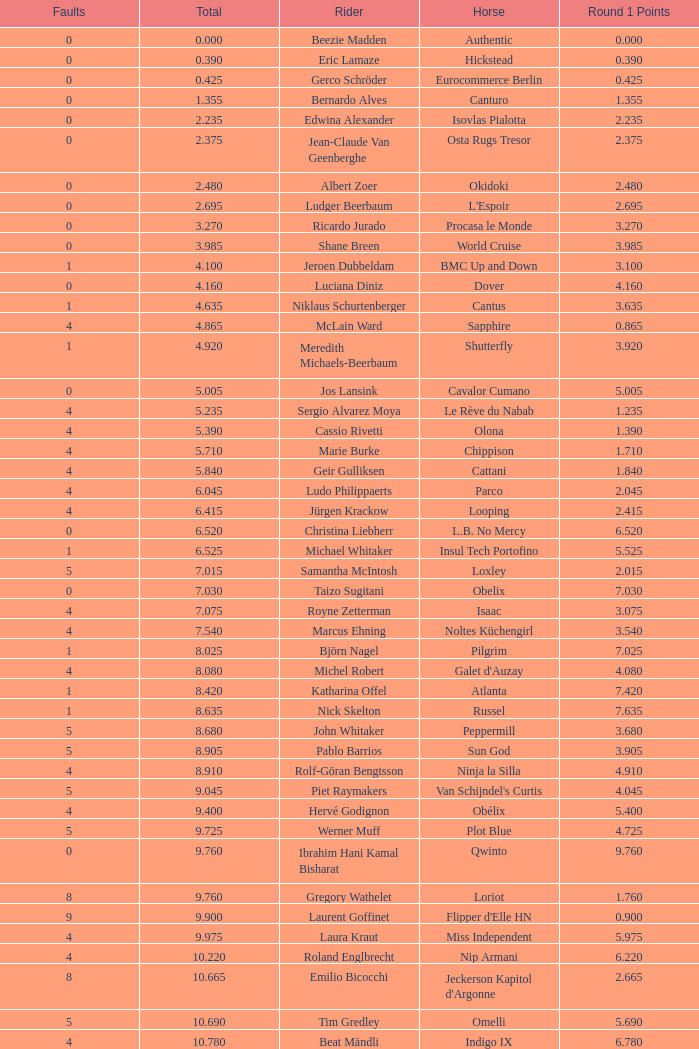Tell me the most total for horse of carlson 29.545. 